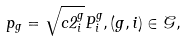Convert formula to latex. <formula><loc_0><loc_0><loc_500><loc_500>p _ { g } = \sqrt { c 2 ^ { g } _ { i } } P ^ { g } _ { i } , ( g , i ) \in \mathcal { G } ,</formula> 